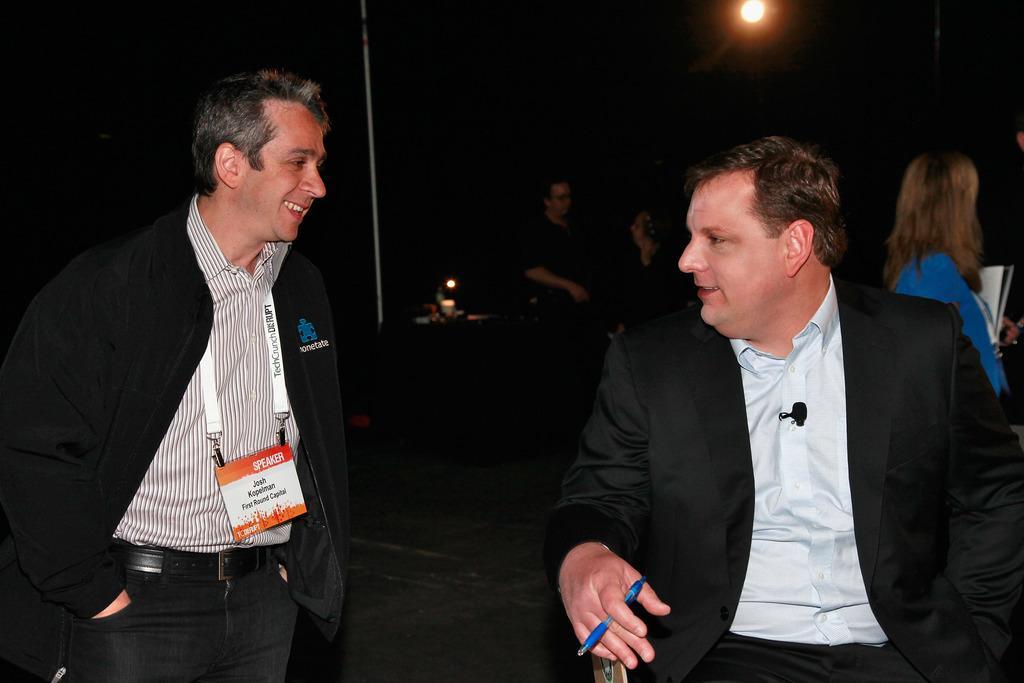Could you give a brief overview of what you see in this image? In this picture there are two men smiling, among them one man sitting and holding a pen, behind these two men there are people and we can see lights and pole. In the background of the image it is dark. 